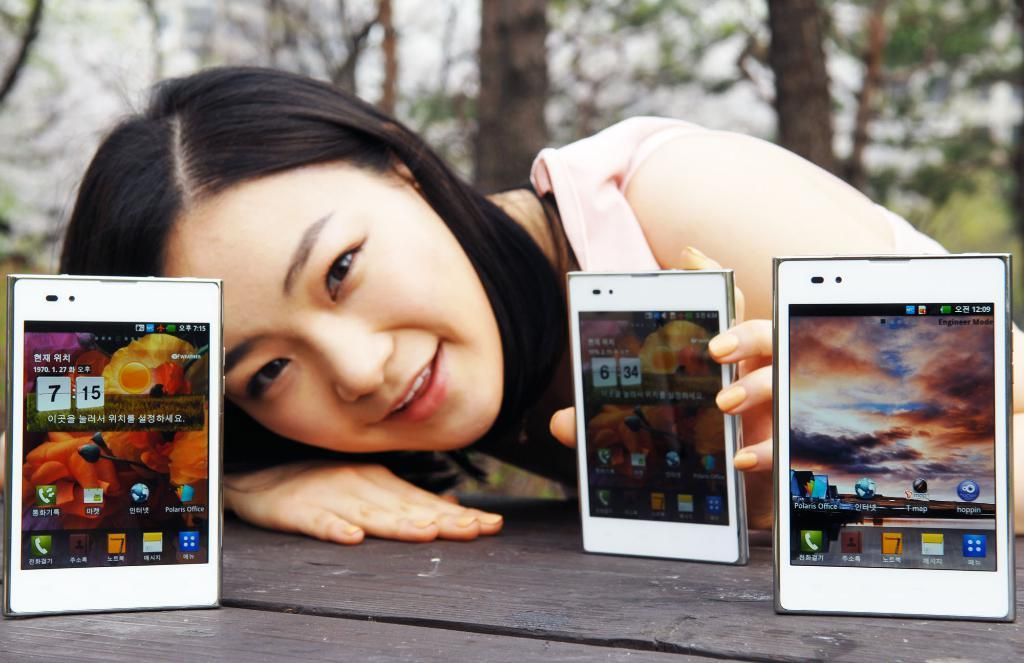What is the woman holding in the image? The woman is holding a mobile. How many mobiles are on the table in the image? There are three mobiles on the table in the image. What can be seen in the background of the image? There are trees in the background of the image. Is there a guitar being played in the quicksand in the image? There is no guitar or quicksand present in the image. 